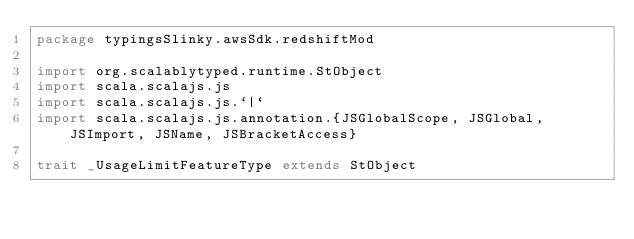Convert code to text. <code><loc_0><loc_0><loc_500><loc_500><_Scala_>package typingsSlinky.awsSdk.redshiftMod

import org.scalablytyped.runtime.StObject
import scala.scalajs.js
import scala.scalajs.js.`|`
import scala.scalajs.js.annotation.{JSGlobalScope, JSGlobal, JSImport, JSName, JSBracketAccess}

trait _UsageLimitFeatureType extends StObject
</code> 